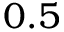<formula> <loc_0><loc_0><loc_500><loc_500>0 . 5</formula> 